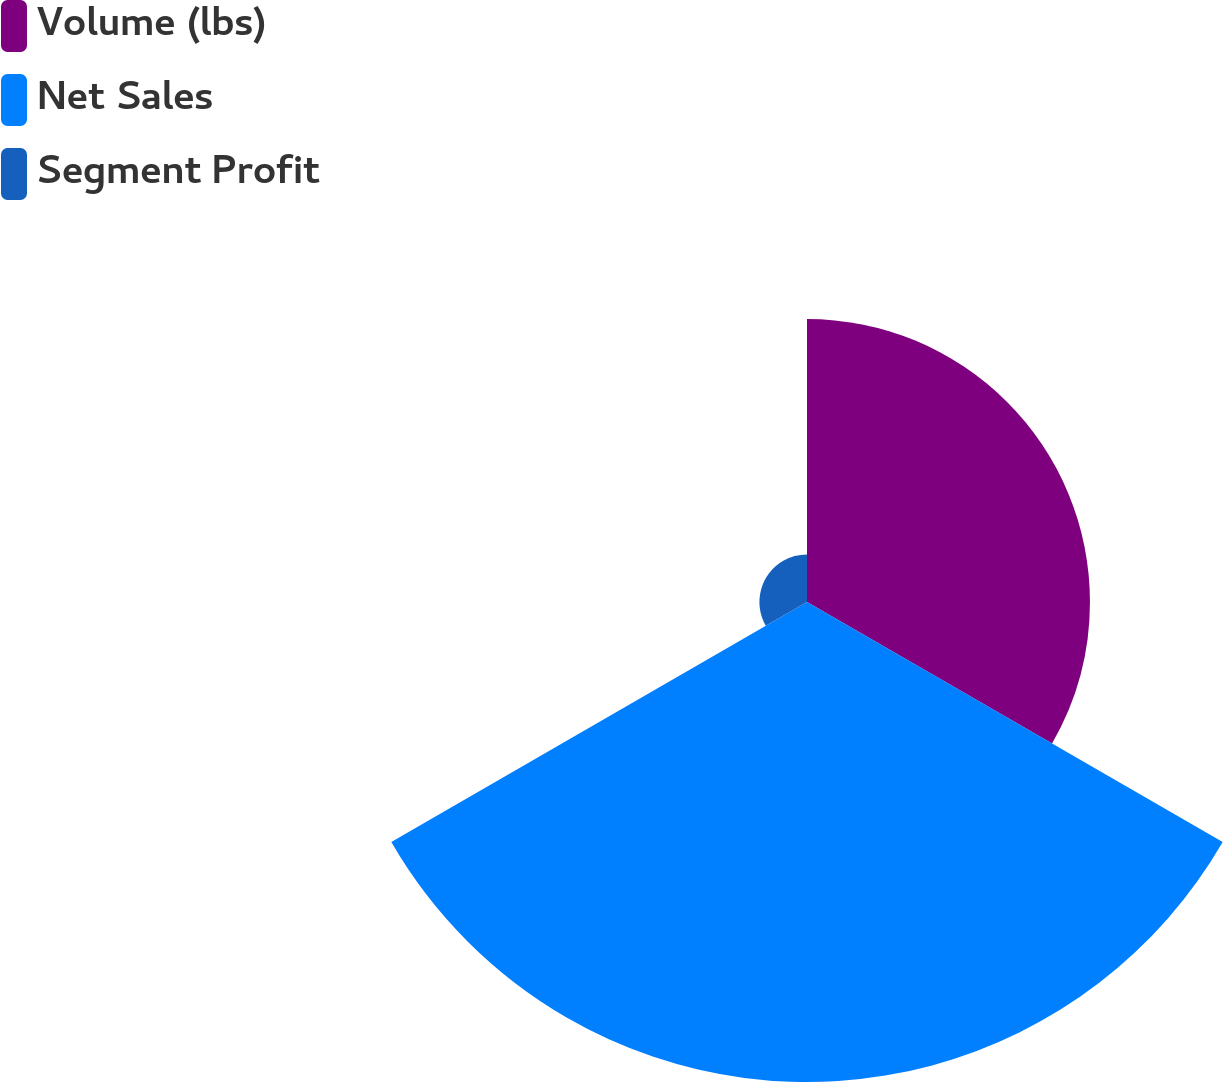<chart> <loc_0><loc_0><loc_500><loc_500><pie_chart><fcel>Volume (lbs)<fcel>Net Sales<fcel>Segment Profit<nl><fcel>34.91%<fcel>59.22%<fcel>5.87%<nl></chart> 